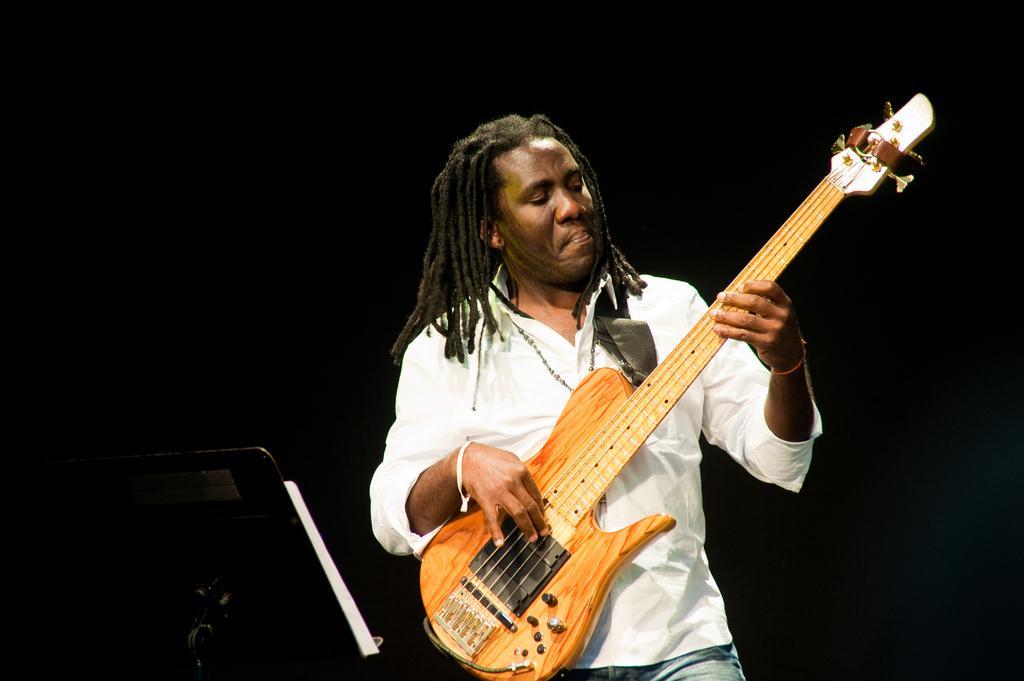Could you give a brief overview of what you see in this image? In this, we can see human is holding a guitar. He is playing the music. He wear white color shirt, jeans. On left side, we can see stand, book. 